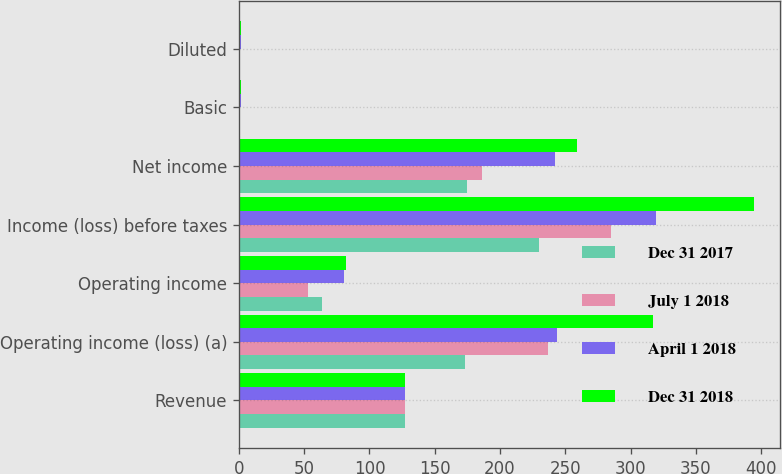Convert chart to OTSL. <chart><loc_0><loc_0><loc_500><loc_500><stacked_bar_chart><ecel><fcel>Revenue<fcel>Operating income (loss) (a)<fcel>Operating income<fcel>Income (loss) before taxes<fcel>Net income<fcel>Basic<fcel>Diluted<nl><fcel>Dec 31 2017<fcel>127.35<fcel>172.8<fcel>63.6<fcel>230.2<fcel>174.8<fcel>1.04<fcel>1.03<nl><fcel>July 1 2018<fcel>127.35<fcel>236.5<fcel>52.6<fcel>284.7<fcel>186.4<fcel>1.06<fcel>1.05<nl><fcel>April 1 2018<fcel>127.35<fcel>243.4<fcel>80.5<fcel>319.4<fcel>242.3<fcel>1.45<fcel>1.45<nl><fcel>Dec 31 2018<fcel>127.35<fcel>317.4<fcel>81.9<fcel>394.4<fcel>258.9<fcel>1.48<fcel>1.48<nl></chart> 